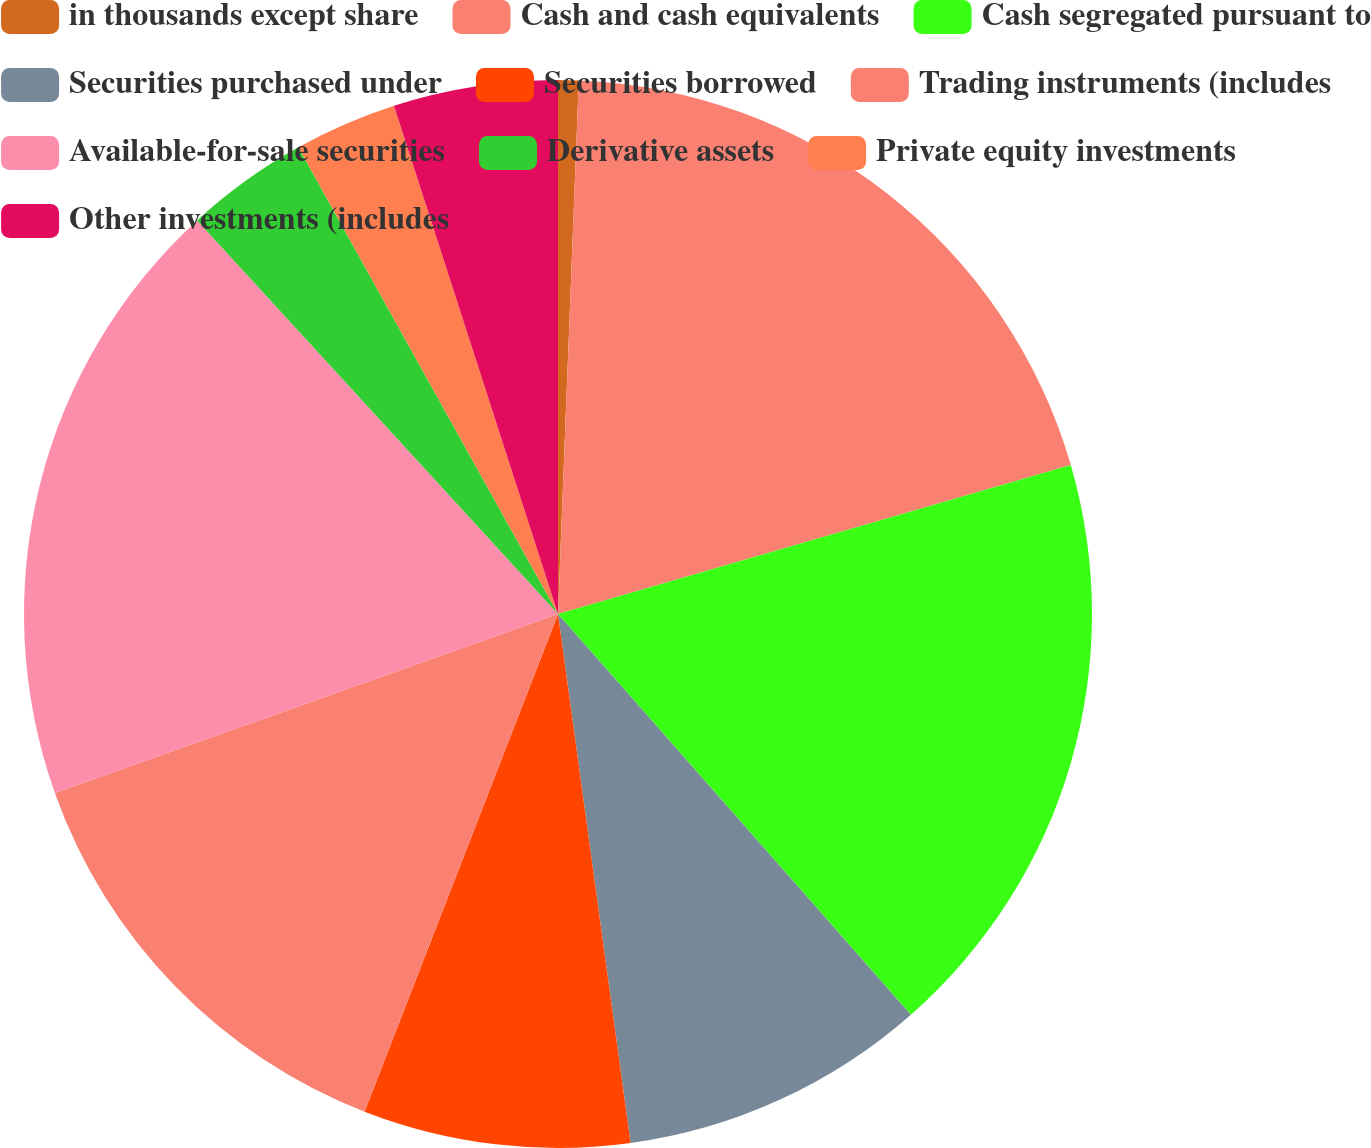Convert chart. <chart><loc_0><loc_0><loc_500><loc_500><pie_chart><fcel>in thousands except share<fcel>Cash and cash equivalents<fcel>Cash segregated pursuant to<fcel>Securities purchased under<fcel>Securities borrowed<fcel>Trading instruments (includes<fcel>Available-for-sale securities<fcel>Derivative assets<fcel>Private equity investments<fcel>Other investments (includes<nl><fcel>0.62%<fcel>19.88%<fcel>18.01%<fcel>9.32%<fcel>8.07%<fcel>13.66%<fcel>18.63%<fcel>3.73%<fcel>3.11%<fcel>4.97%<nl></chart> 